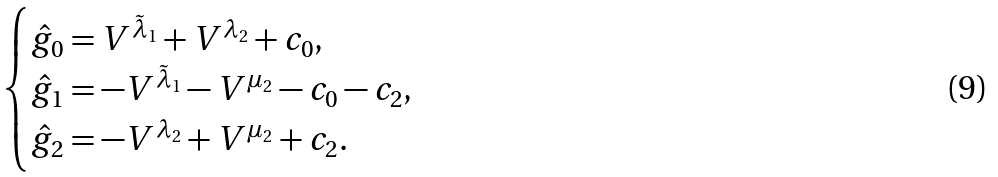Convert formula to latex. <formula><loc_0><loc_0><loc_500><loc_500>\begin{cases} \hat { g } _ { 0 } = V ^ { \tilde { \lambda } _ { 1 } } + V ^ { \lambda _ { 2 } } + c _ { 0 } , \\ \hat { g } _ { 1 } = - V ^ { \tilde { \lambda } _ { 1 } } - V ^ { \mu _ { 2 } } - c _ { 0 } - c _ { 2 } , \\ \hat { g } _ { 2 } = - V ^ { \lambda _ { 2 } } + V ^ { \mu _ { 2 } } + c _ { 2 } . \end{cases}</formula> 